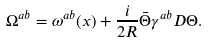<formula> <loc_0><loc_0><loc_500><loc_500>\Omega ^ { a b } = \omega ^ { a b } ( x ) + \frac { i } { 2 R } \bar { \Theta } \gamma ^ { a b } D \Theta .</formula> 